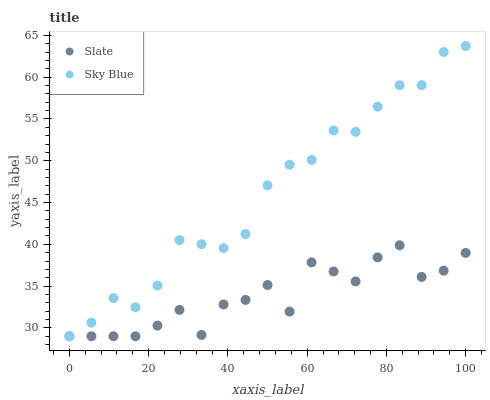Does Slate have the minimum area under the curve?
Answer yes or no. Yes. Does Sky Blue have the maximum area under the curve?
Answer yes or no. Yes. Does Slate have the maximum area under the curve?
Answer yes or no. No. Is Sky Blue the smoothest?
Answer yes or no. Yes. Is Slate the roughest?
Answer yes or no. Yes. Is Slate the smoothest?
Answer yes or no. No. Does Sky Blue have the lowest value?
Answer yes or no. Yes. Does Sky Blue have the highest value?
Answer yes or no. Yes. Does Slate have the highest value?
Answer yes or no. No. Does Sky Blue intersect Slate?
Answer yes or no. Yes. Is Sky Blue less than Slate?
Answer yes or no. No. Is Sky Blue greater than Slate?
Answer yes or no. No. 